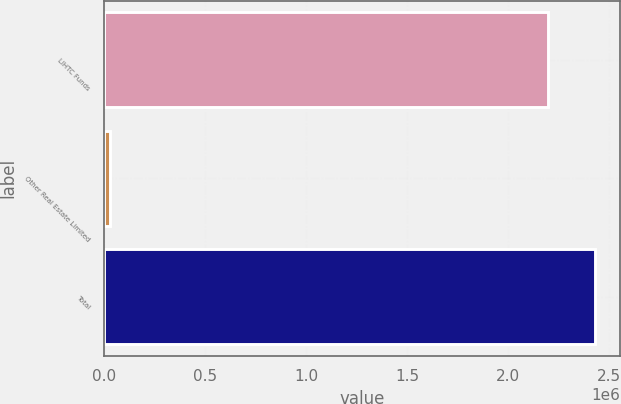Convert chart. <chart><loc_0><loc_0><loc_500><loc_500><bar_chart><fcel>LIHTC Funds<fcel>Other Real Estate Limited<fcel>Total<nl><fcel>2.19805e+06<fcel>31107<fcel>2.43192e+06<nl></chart> 